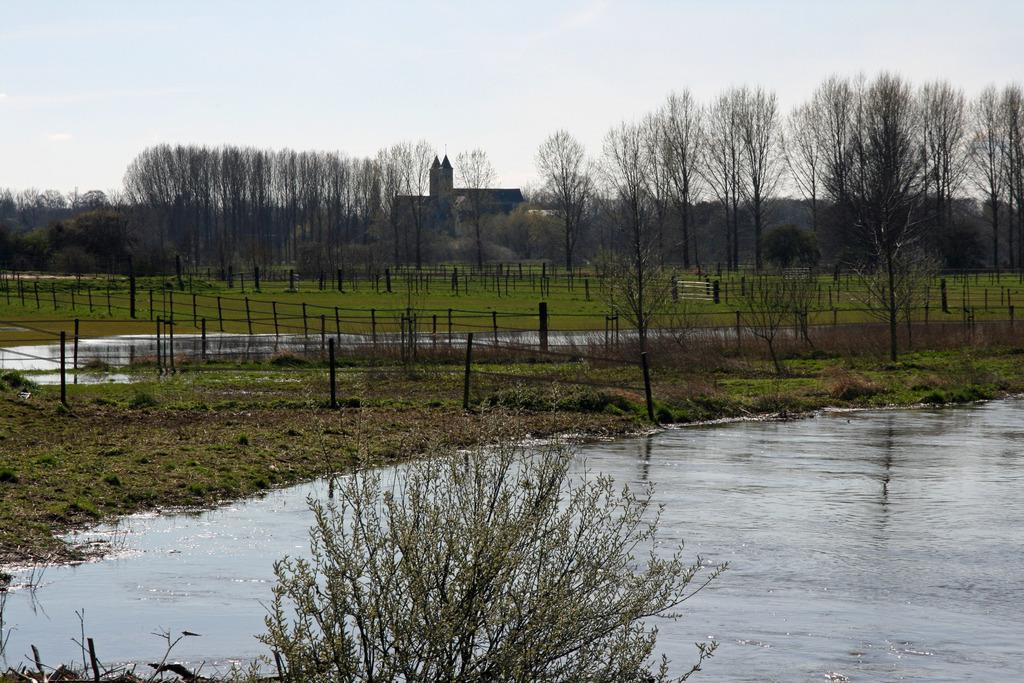What body of water is present in the image? There is a lake in the image. What type of vegetation surrounds the lake? There are trees around the lake. What other types of plants can be seen in the image? There are plants in the image. What type of ground cover is present in the image? There is grass in the image. What structures are present in the image? There are poles and fencing in the image. What shape is the grandfather's stick in the image? There is no grandfather or stick present in the image. 